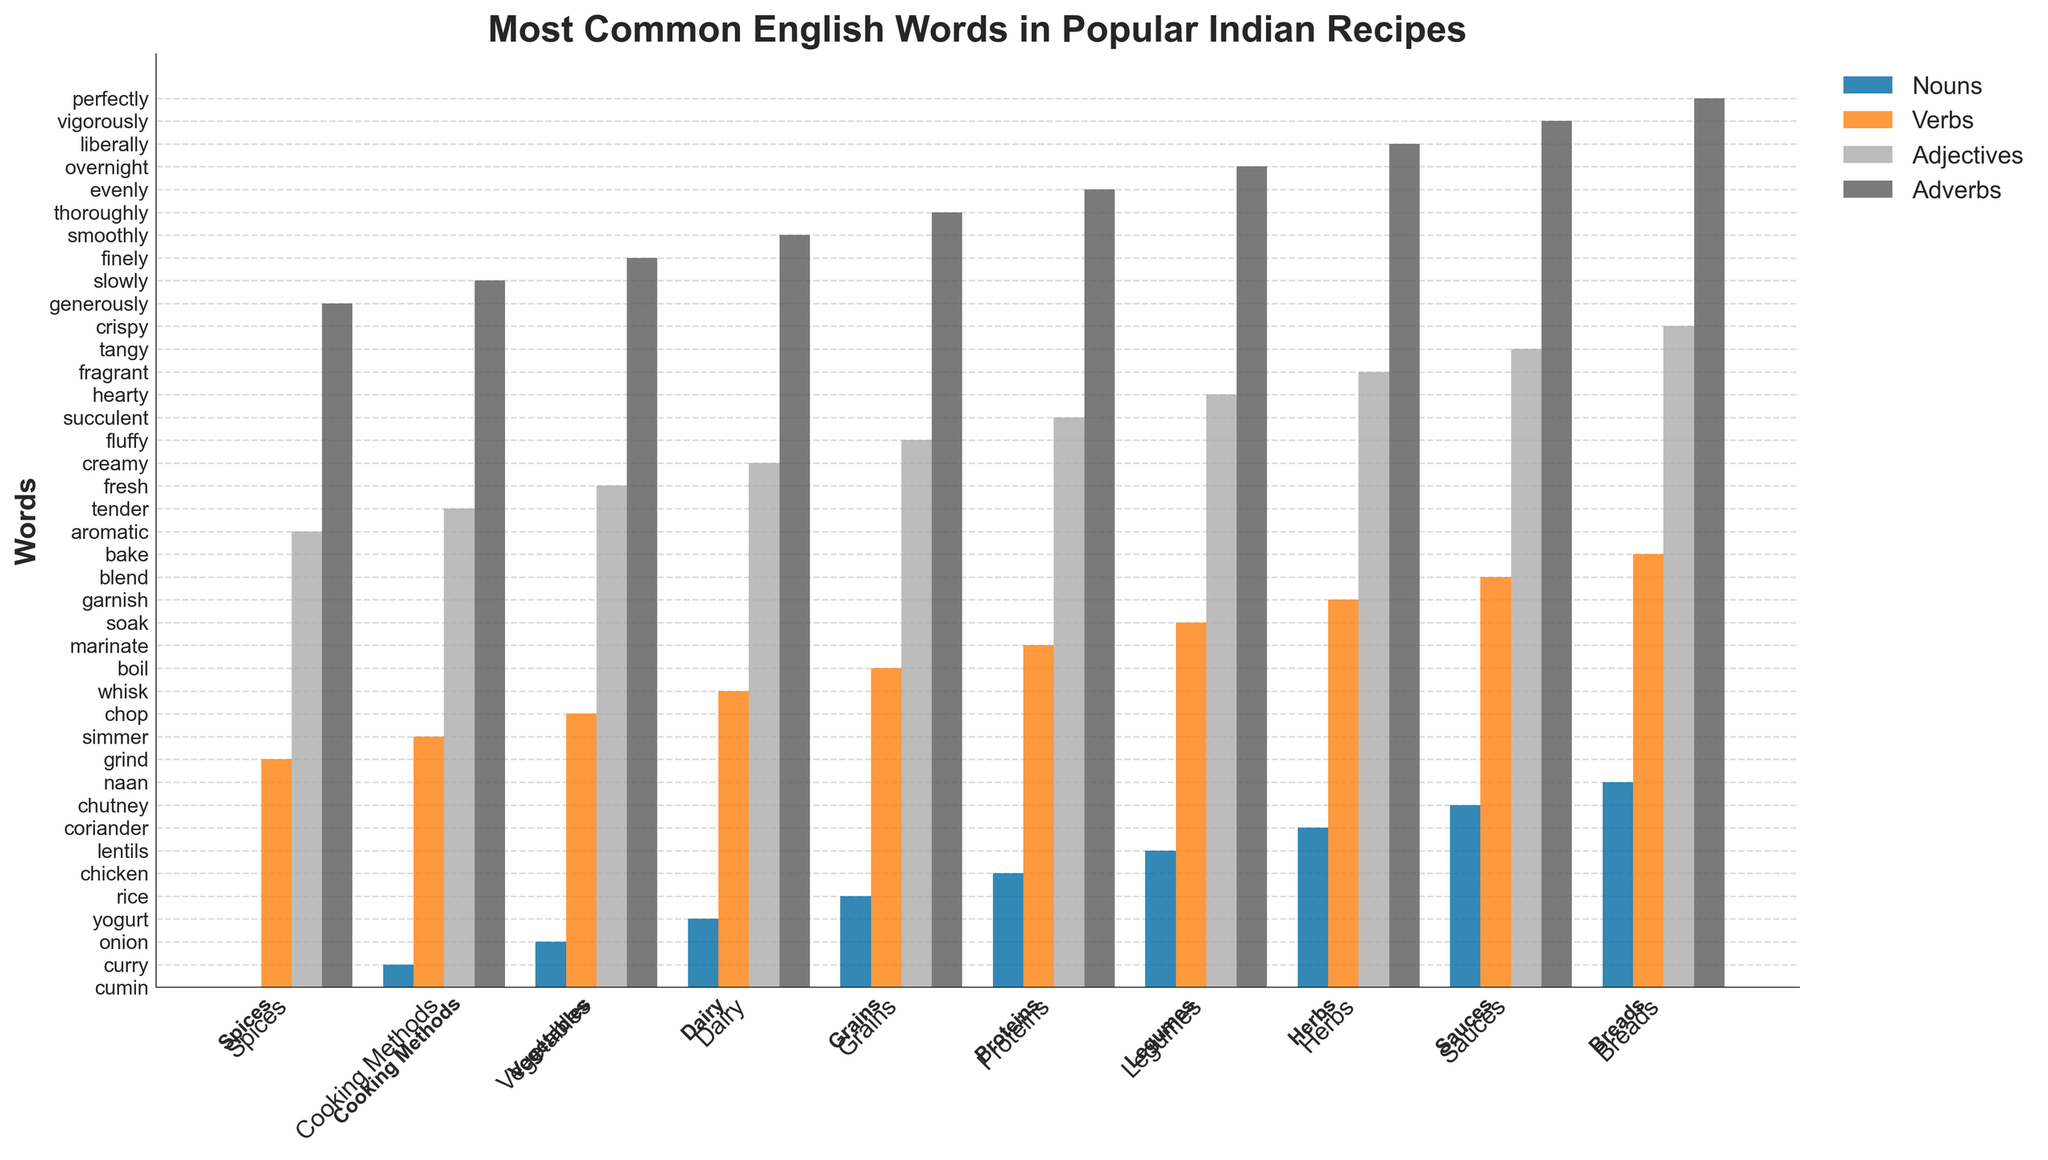Which category has the noun 'coriander'? Look at the chart and identify the bar corresponding to the noun 'coriander'. Then, check the category label on the x-axis directly underneath it.
Answer: Herbs What is the verb associated with the 'Grains' category? Locate the 'Grains' category on the x-axis and then look at the bar representing verbs on top of it.
Answer: boil Which word category does 'succulent' belong to in the 'Proteins' category? Identify the 'Proteins' category on the x-axis and check which part of speech corresponds to 'succulent' in the vertical bars above 'Proteins'.
Answer: Adjectives What is the adjective for 'Dairy'? Find the 'Dairy' category on the x-axis, then look at the bar representing adjectives above it to identify the adjective.
Answer: creamy What is the difference between the nouns of 'Vegetables' and 'Breads'? Identify the nouns above 'Vegetables' and 'Breads' categories and compare them.
Answer: onion and naan Which category's adverb is 'overnight'? Find the bar representing 'overnight' in the adverb section and check the category label on the x-axis directly underneath it.
Answer: Legumes What is the verb associated with the 'Legumes' category? Locate 'Legumes' on the x-axis and check the verb category bar above it.
Answer: soak Which two categories share a verb denoting some form of blending or mixing, and what are those verbs? Check all the verbs for each category and identify those related to blending or mixing. Note their corresponding categories.
Answer: Dairy (whisk) and Sauces (blend) How many categories use verbs related to liquid manipulation (e.g., cook with liquids, stir, pour)? Count the categories where verb involves liquid manipulation by visually identifying verbs like 'simmer', 'boil', 'soak', etc.
Answer: 3 (Cooking Methods, Grains, and Legumes) Which category uses the adverb 'slowly'? Locate the 'slowly' adverb bar and check the category label on the x-axis directly underneath it.
Answer: Cooking Methods 